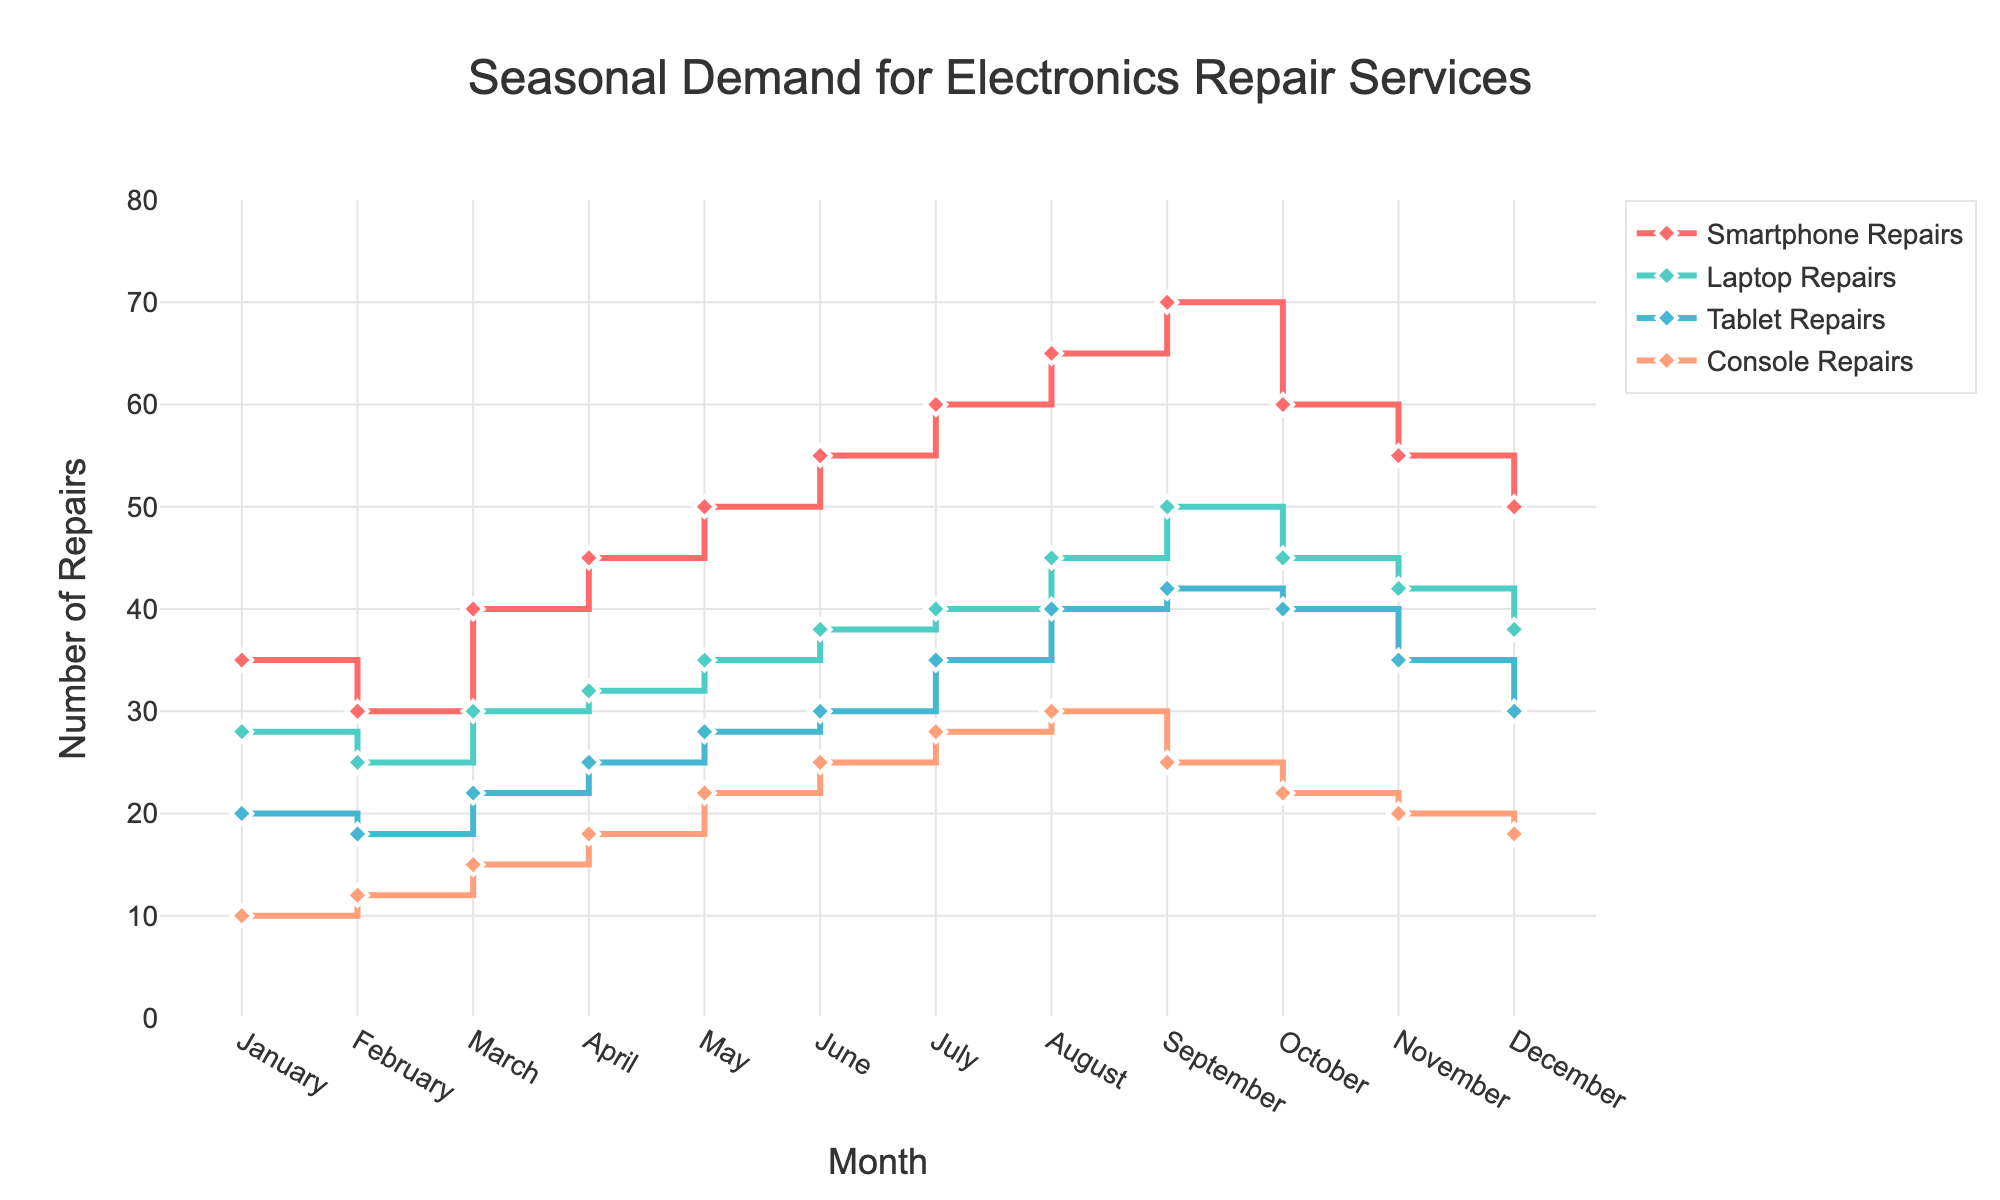Which month has the highest demand for smartphone repairs? The highest point on the smartphone repairs line indicates the highest demand. It occurs in September.
Answer: September During which month is the demand for console repairs the lowest? The lowest point on the console repairs line shows the lowest demand, which is in January.
Answer: January What is the average number of laptop repairs from January to December? Sum the number of laptop repairs from January to December (28 + 25 + 30 + 32 + 35 + 38 + 40 + 45 + 50 + 45 + 42 + 38) = 448, and divide by 12.
Answer: 37.33 In which month is the demand for tablet repairs first greater than 25? Identify the first month where the tablet repairs line goes above 25. That happens in May.
Answer: May How does the demand for smartphone repairs in January compare to the demand in December? The figure shows the demand for smartphone repairs is 35 in January and 50 in December. Compare the two values.
Answer: January: 35, December: 50 What is the total number of console repairs in March, April, and May combined? Sum the number of console repairs for March, April, and May (15 + 18 + 22) = 55.
Answer: 55 Between which months does the number of laptop repairs remain constant? Observe where the laptop repairs line stays flat, indicating no change in the number. It remains constant between July and August.
Answer: July and August What trend do you see in the demand for tablet repairs from June to September? Look at the shape of the tablet repairs line between June and September. The demand increases from June to August and then slightly decreases in September.
Answer: Increases, then slightly decreases Which type of repair shows the most consistent demand throughout the year? Examine the lines for each repair type to see which line looks the least variable over the months. The console repairs line shows the most consistency.
Answer: Console repairs 